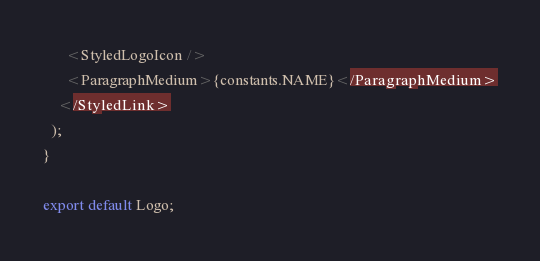Convert code to text. <code><loc_0><loc_0><loc_500><loc_500><_JavaScript_>      <StyledLogoIcon />
      <ParagraphMedium>{constants.NAME}</ParagraphMedium>
    </StyledLink>
  );
}

export default Logo;
</code> 